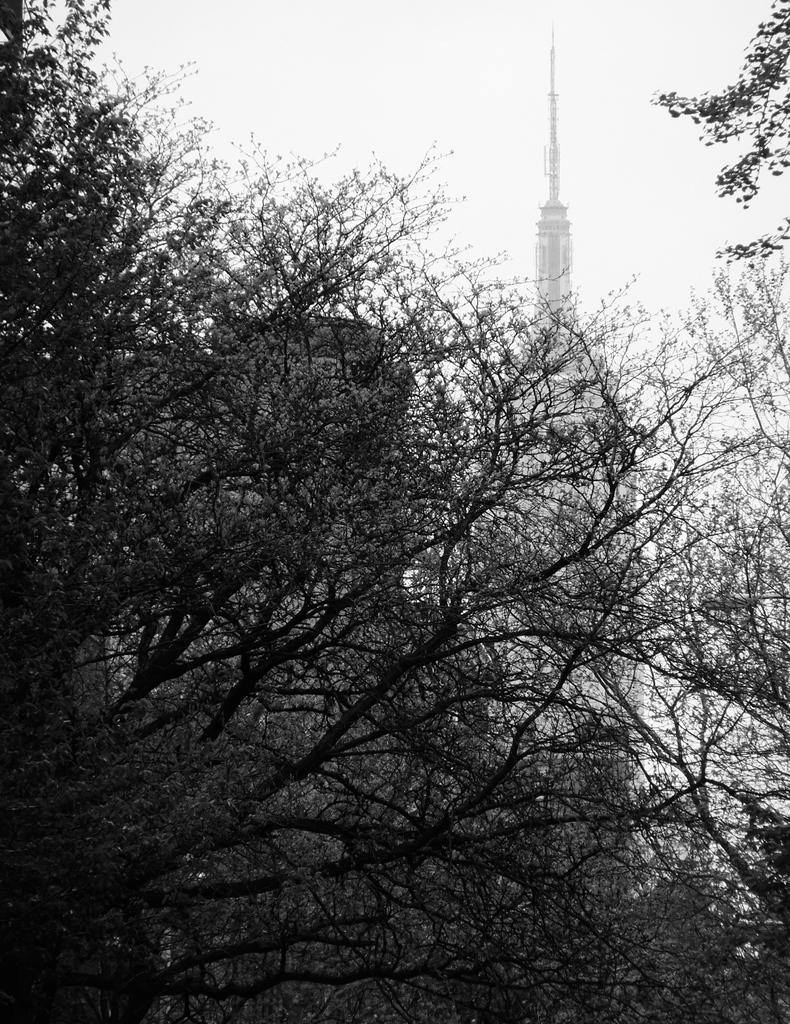What type of vegetation is in the foreground of the image? There are trees in the foreground of the image. What type of structures are visible in the background of the image? There are skyscrapers and other buildings in the background of the image. What is visible at the top of the image? The sky is visible at the top of the image. What sign or title is displayed on the trees in the image? There is no sign or title displayed on the trees in the image; they are simply trees in the foreground. What type of fowl can be seen perched on the skyscrapers in the image? There are no birds or fowl visible on the skyscrapers in the image. 